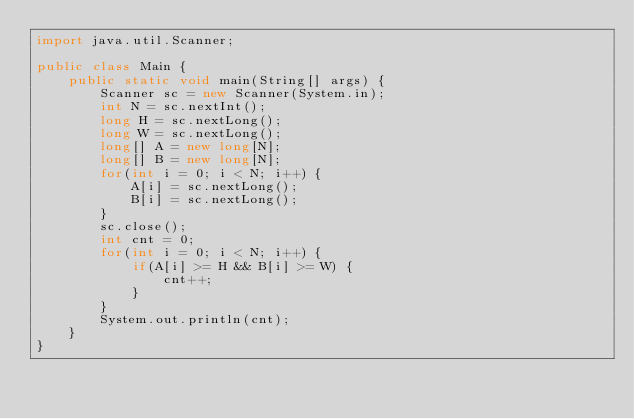Convert code to text. <code><loc_0><loc_0><loc_500><loc_500><_Java_>import java.util.Scanner;

public class Main {
	public static void main(String[] args) {
		Scanner sc = new Scanner(System.in);
		int N = sc.nextInt();
		long H = sc.nextLong();
		long W = sc.nextLong();
		long[] A = new long[N];
		long[] B = new long[N];
		for(int i = 0; i < N; i++) {
			A[i] = sc.nextLong();
			B[i] = sc.nextLong();
		}
		sc.close();
		int cnt = 0;
		for(int i = 0; i < N; i++) {
			if(A[i] >= H && B[i] >= W) {
				cnt++;
			}
		}
		System.out.println(cnt);
	}
}</code> 